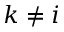Convert formula to latex. <formula><loc_0><loc_0><loc_500><loc_500>k \ne i</formula> 